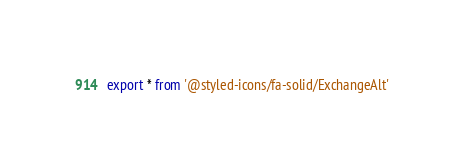Convert code to text. <code><loc_0><loc_0><loc_500><loc_500><_TypeScript_>export * from '@styled-icons/fa-solid/ExchangeAlt'</code> 